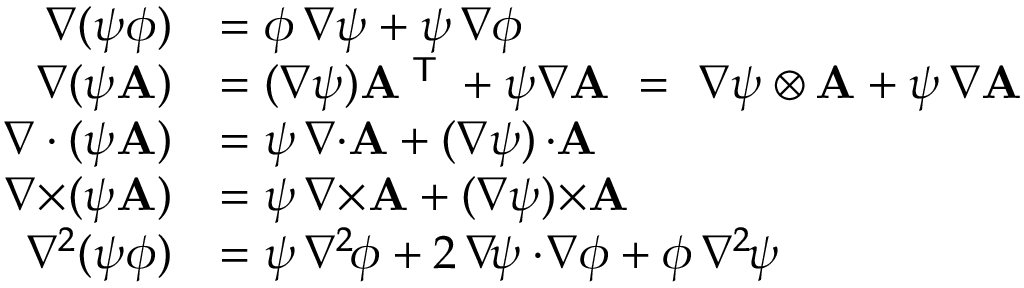Convert formula to latex. <formula><loc_0><loc_0><loc_500><loc_500>{ \begin{array} { r l } { \nabla ( \psi \phi ) } & { = \phi \, \nabla \psi + \psi \, \nabla \phi } \\ { \nabla ( \psi A ) } & { = ( \nabla \psi ) A ^ { T } + \psi \nabla A \ = \ \nabla \psi \otimes A + \psi \, \nabla A } \\ { \nabla \cdot ( \psi A ) } & { = \psi \, \nabla { \cdot } A + ( \nabla \psi ) \, { \cdot } A } \\ { \nabla { \times } ( \psi A ) } & { = \psi \, \nabla { \times } A + ( \nabla \psi ) { \times } A } \\ { \nabla ^ { 2 } ( \psi \phi ) } & { = \psi \, \nabla ^ { 2 \, } \phi + 2 \, \nabla \, \psi \cdot \, \nabla \phi + \phi \, \nabla ^ { 2 \, } \psi } \end{array} }</formula> 